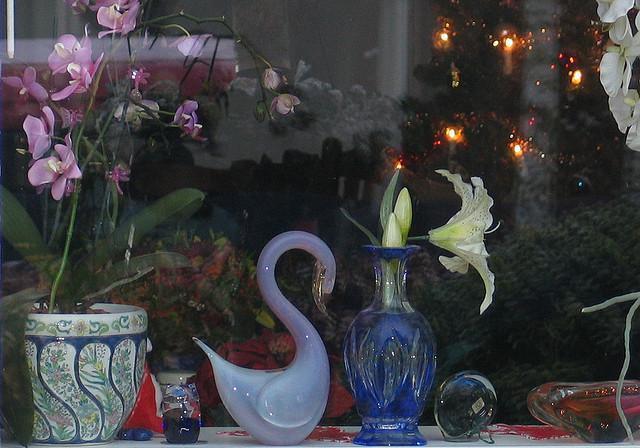How many vases are there?
Give a very brief answer. 2. How many potted plants can be seen?
Give a very brief answer. 2. How many people are holding a bag?
Give a very brief answer. 0. 